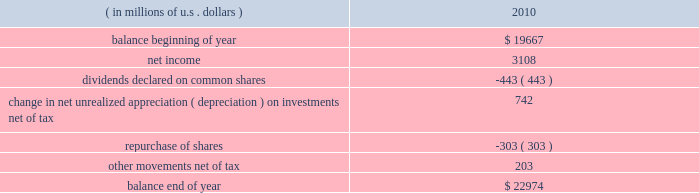The table reports the significant movements in our shareholders 2019 equity for the year ended december 31 , 2010. .
Total shareholders 2019 equity increased $ 3.3 billion in 2010 , primarily due to net income of $ 3.1 billion and the change in net unrealized appreciation on investments of $ 742 million .
Short-term debt at december 31 , 2010 , in connection with the financing of the rain and hail acquisition , short-term debt includes reverse repurchase agreements totaling $ 1 billion .
In addition , $ 300 million in borrowings against ace 2019s revolving credit facility were outstanding at december 31 , 2010 .
At december 31 , 2009 , short-term debt consisted of a five-year term loan which we repaid in december 2010 .
Long-term debt our total long-term debt increased by $ 200 million during the year to $ 3.4 billion and is described in detail in note 9 to the consolidated financial statements , under item 8 .
In november 2010 , ace ina issued $ 700 million of 2.6 percent senior notes due november 2015 .
These senior unsecured notes are guaranteed on a senior basis by the company and they rank equally with all of the company 2019s other senior obligations .
In april 2008 , as part of the financing of the combined insurance acquisition , ace ina entered into a $ 450 million float- ing interest rate syndicated term loan agreement due april 2013 .
Simultaneously , the company entered into a swap transaction that had the economic effect of fixing the interest rate for the term of the loan .
In december 2010 , ace repaid this loan and exited the swap .
In december 2008 , ace ina entered into a $ 66 million dual tranche floating interest rate term loan agreement .
The first tranche , a $ 50 million three-year term loan due december 2011 , had a floating interest rate .
Simultaneously , the company entered into a swap transaction that had the economic effect of fixing the interest rate for the term of the loan .
In december 2010 , ace repaid this loan and exited the swap .
The second tranche , a $ 16 million nine-month term loan , was due and repaid in september 2009 .
Trust preferred securities the securities outstanding consist of $ 300 million of trust preferred securities due 2030 , issued by a special purpose entity ( a trust ) that is wholly owned by us .
The sole assets of the special purpose entity are debt instruments issued by one or more of our subsidiaries .
The special purpose entity looks to payments on the debt instruments to make payments on the preferred securities .
We have guaranteed the payments on these debt instruments .
The trustees of the trust include one or more of our officers and at least one independent trustee , such as a trust company .
Our officers serving as trustees of the trust do not receive any compensation or other remuneration for their services in such capacity .
The full $ 309 million of outstanding trust preferred securities ( calculated as $ 300 million as discussed above plus our equity share of the trust ) is shown on our con- solidated balance sheet as a liability .
Additional information with respect to the trust preferred securities is contained in note 9 d ) to the consolidated financial statements , under item 8 .
Common shares our common shares had a par value of chf 30.57 each at december 31 , 2010 .
At the annual general meeting held in may 2010 , the company 2019s shareholders approved a par value reduction in an aggregate swiss franc amount , pursuant to a formula , equal to $ 1.32 per share , which we refer to as the base annual divi- dend .
The base annual dividend is payable in four installments , provided that each of the swiss franc installments will be .
What is the dividend payout in 2010? 
Computations: (443 / 3108)
Answer: 0.14254. 